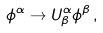<formula> <loc_0><loc_0><loc_500><loc_500>\phi ^ { \alpha } \rightarrow U _ { \beta } ^ { \alpha } \phi ^ { \beta } \, ,</formula> 